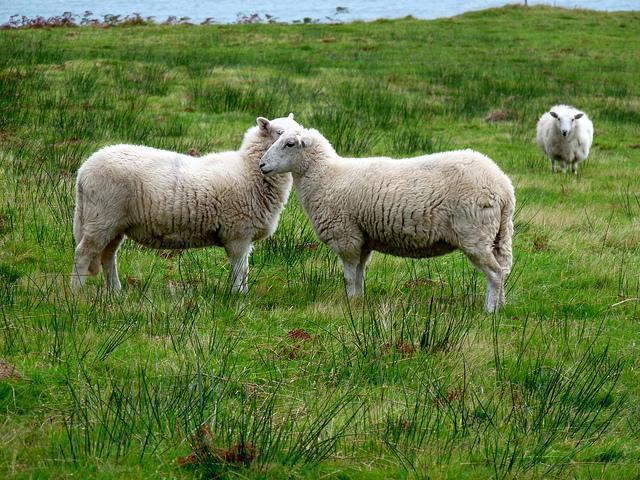How many sheep are standing around in the cape field?
Select the accurate response from the four choices given to answer the question.
Options: Two, four, six, three. Three. 